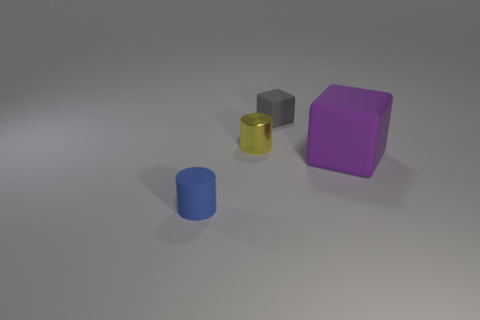Is there anything else that has the same material as the yellow object?
Give a very brief answer. No. Is there any other thing that has the same size as the purple cube?
Provide a short and direct response. No. What shape is the blue thing that is made of the same material as the large purple object?
Your answer should be very brief. Cylinder. Is there any other thing that has the same shape as the gray object?
Provide a succinct answer. Yes. What is the shape of the shiny object?
Offer a terse response. Cylinder. There is a gray rubber thing to the right of the blue cylinder; is it the same shape as the big purple thing?
Provide a short and direct response. Yes. Are there more tiny cylinders in front of the yellow cylinder than metallic cylinders that are in front of the large matte object?
Offer a very short reply. Yes. What number of other objects are the same size as the yellow cylinder?
Your response must be concise. 2. Is the shape of the small gray matte object the same as the object that is in front of the purple matte cube?
Your answer should be very brief. No. How many shiny things are yellow spheres or yellow objects?
Offer a terse response. 1. 